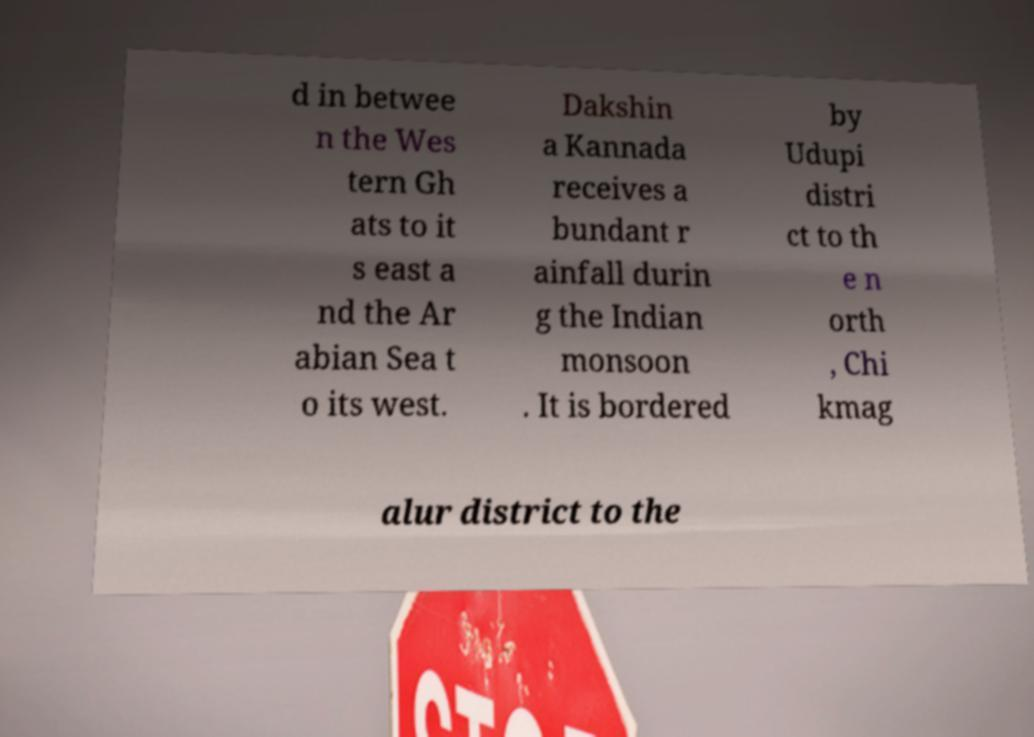Could you extract and type out the text from this image? d in betwee n the Wes tern Gh ats to it s east a nd the Ar abian Sea t o its west. Dakshin a Kannada receives a bundant r ainfall durin g the Indian monsoon . It is bordered by Udupi distri ct to th e n orth , Chi kmag alur district to the 